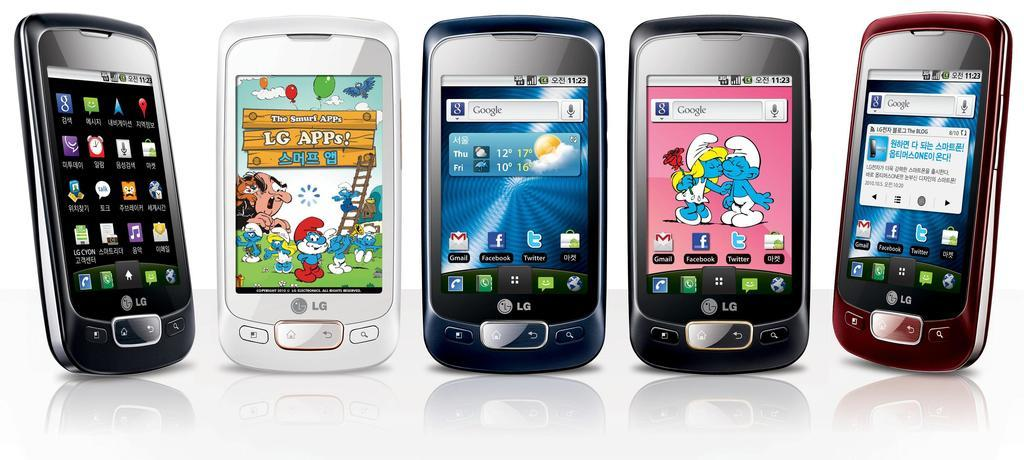<image>
Share a concise interpretation of the image provided. A collection of LG phones with varying color schemes and backgrounds. 